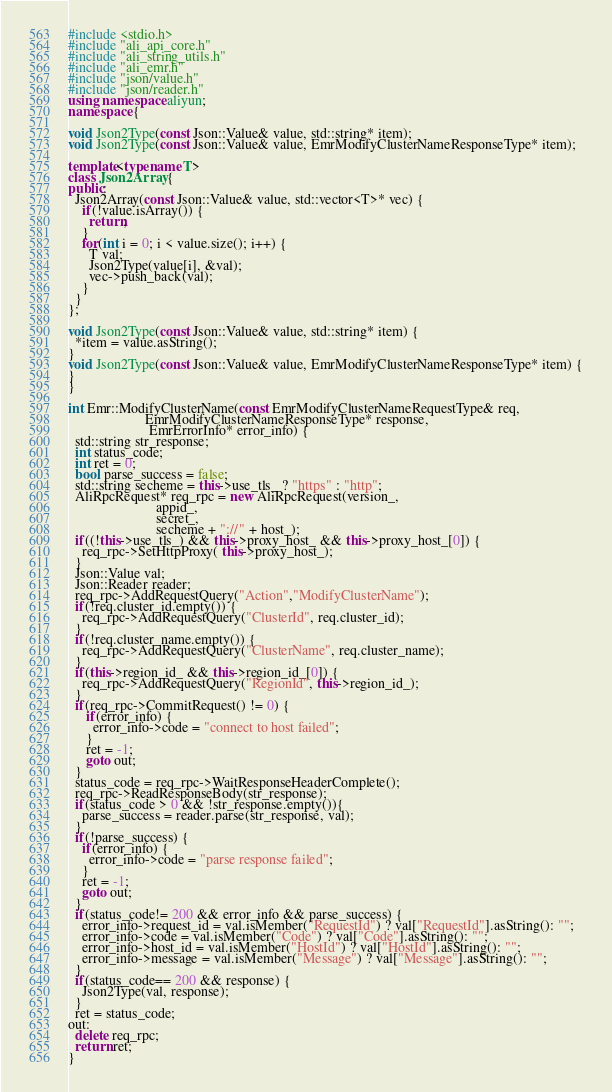<code> <loc_0><loc_0><loc_500><loc_500><_C++_>#include <stdio.h>
#include "ali_api_core.h"
#include "ali_string_utils.h"
#include "ali_emr.h"
#include "json/value.h"
#include "json/reader.h"
using namespace aliyun;
namespace {

void Json2Type(const Json::Value& value, std::string* item);
void Json2Type(const Json::Value& value, EmrModifyClusterNameResponseType* item);

template<typename T>
class Json2Array {
public:
  Json2Array(const Json::Value& value, std::vector<T>* vec) {
    if(!value.isArray()) {
      return;
    }
    for(int i = 0; i < value.size(); i++) {
      T val;
      Json2Type(value[i], &val);
      vec->push_back(val);
    }
  }
};

void Json2Type(const Json::Value& value, std::string* item) {
  *item = value.asString();
}
void Json2Type(const Json::Value& value, EmrModifyClusterNameResponseType* item) {
}
}

int Emr::ModifyClusterName(const EmrModifyClusterNameRequestType& req,
                      EmrModifyClusterNameResponseType* response,
                       EmrErrorInfo* error_info) {
  std::string str_response;
  int status_code;
  int ret = 0;
  bool parse_success = false;
  std::string secheme = this->use_tls_ ? "https" : "http";
  AliRpcRequest* req_rpc = new AliRpcRequest(version_,
                         appid_,
                         secret_,
                         secheme + "://" + host_);
  if((!this->use_tls_) && this->proxy_host_ && this->proxy_host_[0]) {
    req_rpc->SetHttpProxy( this->proxy_host_);
  }
  Json::Value val;
  Json::Reader reader;
  req_rpc->AddRequestQuery("Action","ModifyClusterName");
  if(!req.cluster_id.empty()) {
    req_rpc->AddRequestQuery("ClusterId", req.cluster_id);
  }
  if(!req.cluster_name.empty()) {
    req_rpc->AddRequestQuery("ClusterName", req.cluster_name);
  }
  if(this->region_id_ && this->region_id_[0]) {
    req_rpc->AddRequestQuery("RegionId", this->region_id_);
  }
  if(req_rpc->CommitRequest() != 0) {
     if(error_info) {
       error_info->code = "connect to host failed";
     }
     ret = -1;
     goto out;
  }
  status_code = req_rpc->WaitResponseHeaderComplete();
  req_rpc->ReadResponseBody(str_response);
  if(status_code > 0 && !str_response.empty()){
    parse_success = reader.parse(str_response, val);
  }
  if(!parse_success) {
    if(error_info) {
      error_info->code = "parse response failed";
    }
    ret = -1;
    goto out;
  }
  if(status_code!= 200 && error_info && parse_success) {
    error_info->request_id = val.isMember("RequestId") ? val["RequestId"].asString(): "";
    error_info->code = val.isMember("Code") ? val["Code"].asString(): "";
    error_info->host_id = val.isMember("HostId") ? val["HostId"].asString(): "";
    error_info->message = val.isMember("Message") ? val["Message"].asString(): "";
  }
  if(status_code== 200 && response) {
    Json2Type(val, response);
  }
  ret = status_code;
out:
  delete req_rpc;
  return ret;
}
</code> 